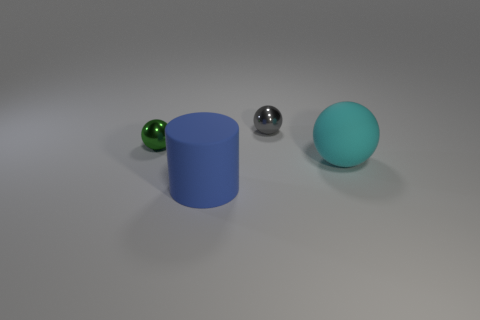Subtract all large balls. How many balls are left? 2 Add 4 green things. How many objects exist? 8 Subtract all gray balls. How many balls are left? 2 Subtract 1 balls. How many balls are left? 2 Subtract all cylinders. How many objects are left? 3 Subtract 0 red cylinders. How many objects are left? 4 Subtract all purple cylinders. Subtract all green spheres. How many cylinders are left? 1 Subtract all cylinders. Subtract all green matte cubes. How many objects are left? 3 Add 1 metal balls. How many metal balls are left? 3 Add 4 small green metallic objects. How many small green metallic objects exist? 5 